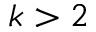Convert formula to latex. <formula><loc_0><loc_0><loc_500><loc_500>k > 2</formula> 